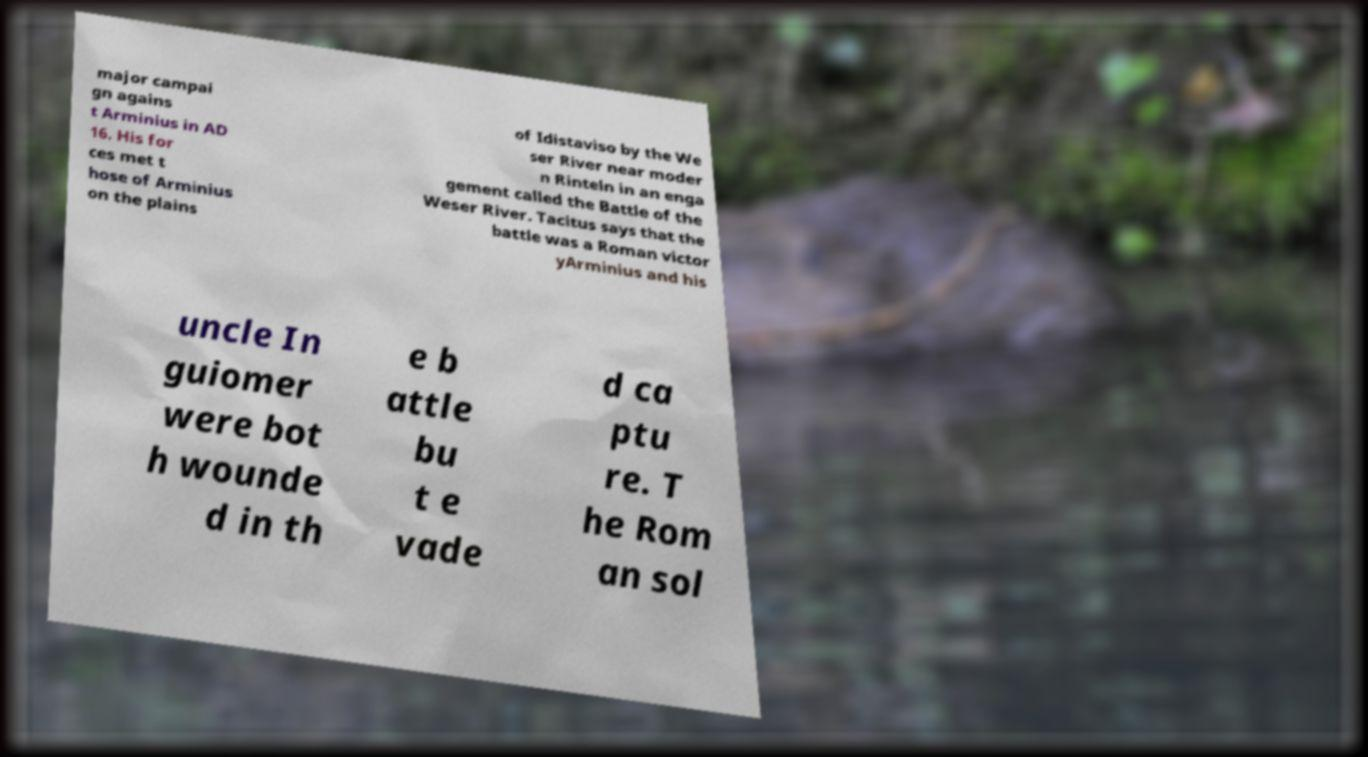I need the written content from this picture converted into text. Can you do that? major campai gn agains t Arminius in AD 16. His for ces met t hose of Arminius on the plains of Idistaviso by the We ser River near moder n Rinteln in an enga gement called the Battle of the Weser River. Tacitus says that the battle was a Roman victor yArminius and his uncle In guiomer were bot h wounde d in th e b attle bu t e vade d ca ptu re. T he Rom an sol 